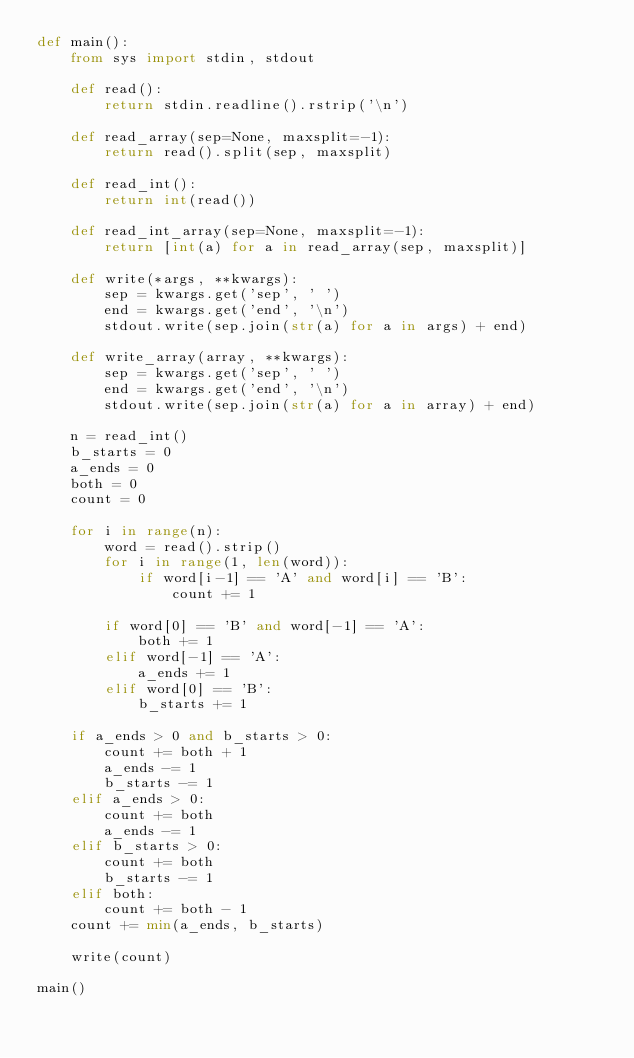Convert code to text. <code><loc_0><loc_0><loc_500><loc_500><_Python_>def main():
    from sys import stdin, stdout

    def read():
        return stdin.readline().rstrip('\n')

    def read_array(sep=None, maxsplit=-1):
        return read().split(sep, maxsplit)

    def read_int():
        return int(read())

    def read_int_array(sep=None, maxsplit=-1):
        return [int(a) for a in read_array(sep, maxsplit)]

    def write(*args, **kwargs):
        sep = kwargs.get('sep', ' ')
        end = kwargs.get('end', '\n')
        stdout.write(sep.join(str(a) for a in args) + end)

    def write_array(array, **kwargs):
        sep = kwargs.get('sep', ' ')
        end = kwargs.get('end', '\n')
        stdout.write(sep.join(str(a) for a in array) + end)

    n = read_int()
    b_starts = 0
    a_ends = 0
    both = 0
    count = 0

    for i in range(n):
        word = read().strip()
        for i in range(1, len(word)):
            if word[i-1] == 'A' and word[i] == 'B':
                count += 1

        if word[0] == 'B' and word[-1] == 'A':
            both += 1
        elif word[-1] == 'A':
            a_ends += 1
        elif word[0] == 'B':
            b_starts += 1

    if a_ends > 0 and b_starts > 0:
        count += both + 1
        a_ends -= 1
        b_starts -= 1
    elif a_ends > 0:
        count += both
        a_ends -= 1
    elif b_starts > 0:
        count += both
        b_starts -= 1
    elif both:
        count += both - 1
    count += min(a_ends, b_starts)

    write(count)

main()
</code> 